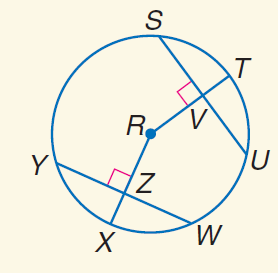Answer the mathemtical geometry problem and directly provide the correct option letter.
Question: In \odot R, S U = 20, Y W = 20, and m \widehat Y X = 45. Find S V.
Choices: A: 10 B: 15 C: 20 D: 45 A 